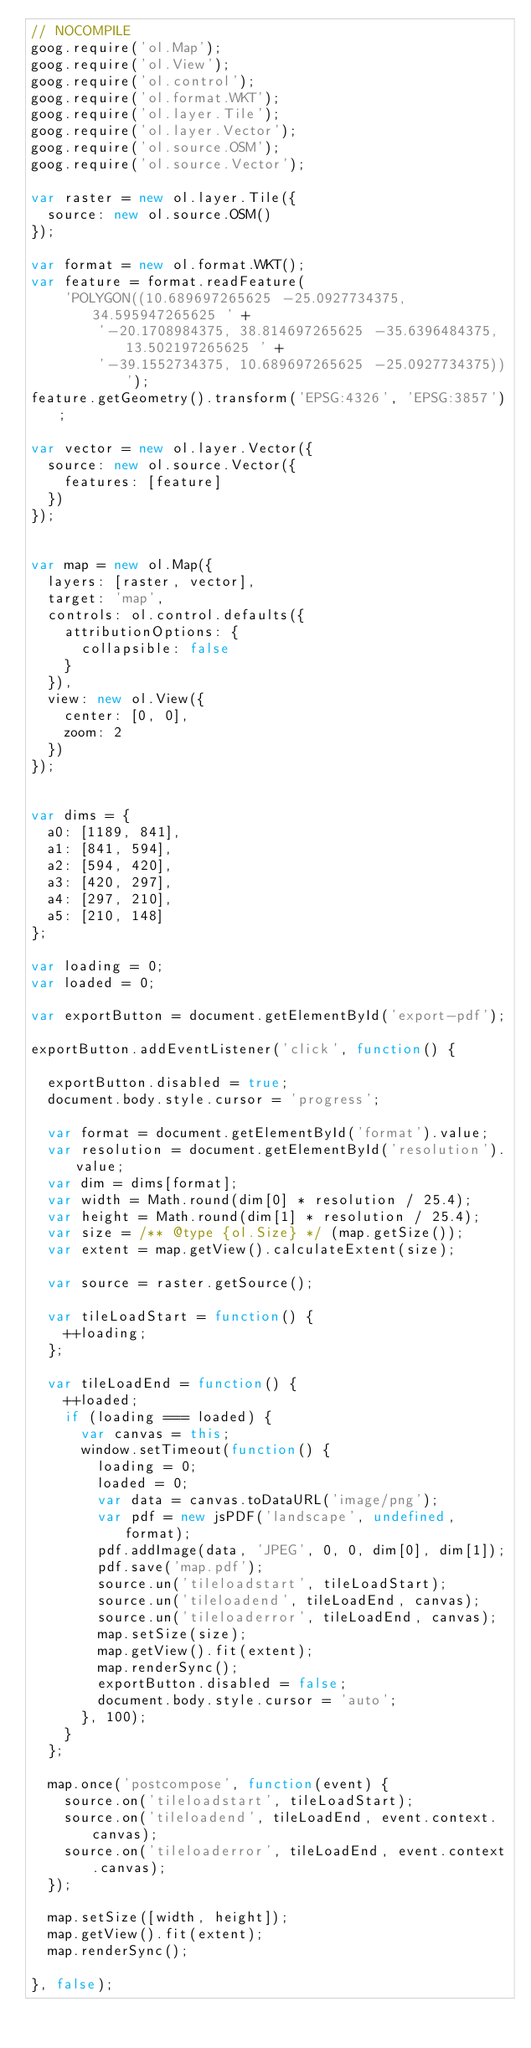Convert code to text. <code><loc_0><loc_0><loc_500><loc_500><_JavaScript_>// NOCOMPILE
goog.require('ol.Map');
goog.require('ol.View');
goog.require('ol.control');
goog.require('ol.format.WKT');
goog.require('ol.layer.Tile');
goog.require('ol.layer.Vector');
goog.require('ol.source.OSM');
goog.require('ol.source.Vector');

var raster = new ol.layer.Tile({
  source: new ol.source.OSM()
});

var format = new ol.format.WKT();
var feature = format.readFeature(
    'POLYGON((10.689697265625 -25.0927734375, 34.595947265625 ' +
        '-20.1708984375, 38.814697265625 -35.6396484375, 13.502197265625 ' +
        '-39.1552734375, 10.689697265625 -25.0927734375))');
feature.getGeometry().transform('EPSG:4326', 'EPSG:3857');

var vector = new ol.layer.Vector({
  source: new ol.source.Vector({
    features: [feature]
  })
});


var map = new ol.Map({
  layers: [raster, vector],
  target: 'map',
  controls: ol.control.defaults({
    attributionOptions: {
      collapsible: false
    }
  }),
  view: new ol.View({
    center: [0, 0],
    zoom: 2
  })
});


var dims = {
  a0: [1189, 841],
  a1: [841, 594],
  a2: [594, 420],
  a3: [420, 297],
  a4: [297, 210],
  a5: [210, 148]
};

var loading = 0;
var loaded = 0;

var exportButton = document.getElementById('export-pdf');

exportButton.addEventListener('click', function() {

  exportButton.disabled = true;
  document.body.style.cursor = 'progress';

  var format = document.getElementById('format').value;
  var resolution = document.getElementById('resolution').value;
  var dim = dims[format];
  var width = Math.round(dim[0] * resolution / 25.4);
  var height = Math.round(dim[1] * resolution / 25.4);
  var size = /** @type {ol.Size} */ (map.getSize());
  var extent = map.getView().calculateExtent(size);

  var source = raster.getSource();

  var tileLoadStart = function() {
    ++loading;
  };

  var tileLoadEnd = function() {
    ++loaded;
    if (loading === loaded) {
      var canvas = this;
      window.setTimeout(function() {
        loading = 0;
        loaded = 0;
        var data = canvas.toDataURL('image/png');
        var pdf = new jsPDF('landscape', undefined, format);
        pdf.addImage(data, 'JPEG', 0, 0, dim[0], dim[1]);
        pdf.save('map.pdf');
        source.un('tileloadstart', tileLoadStart);
        source.un('tileloadend', tileLoadEnd, canvas);
        source.un('tileloaderror', tileLoadEnd, canvas);
        map.setSize(size);
        map.getView().fit(extent);
        map.renderSync();
        exportButton.disabled = false;
        document.body.style.cursor = 'auto';
      }, 100);
    }
  };

  map.once('postcompose', function(event) {
    source.on('tileloadstart', tileLoadStart);
    source.on('tileloadend', tileLoadEnd, event.context.canvas);
    source.on('tileloaderror', tileLoadEnd, event.context.canvas);
  });

  map.setSize([width, height]);
  map.getView().fit(extent);
  map.renderSync();

}, false);
</code> 